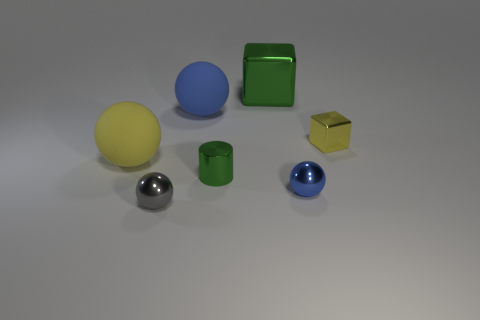There is a yellow thing that is left of the small sphere that is left of the green block; what is its shape?
Keep it short and to the point. Sphere. There is a block that is in front of the blue thing that is behind the green metallic thing that is in front of the big blue sphere; what is its size?
Offer a terse response. Small. Does the yellow ball have the same size as the blue metallic thing?
Your response must be concise. No. How many things are cylinders or small things?
Offer a terse response. 4. There is a yellow thing that is on the right side of the cylinder behind the tiny blue metal sphere; what is its size?
Provide a short and direct response. Small. How big is the yellow matte object?
Offer a very short reply. Large. There is a metal object that is behind the green shiny cylinder and in front of the blue matte object; what is its shape?
Ensure brevity in your answer.  Cube. What is the color of the other tiny shiny object that is the same shape as the tiny gray metallic thing?
Your response must be concise. Blue. What number of things are metal spheres that are to the right of the large green metal cube or shiny things that are to the right of the small gray ball?
Offer a terse response. 4. What shape is the large shiny object?
Keep it short and to the point. Cube. 